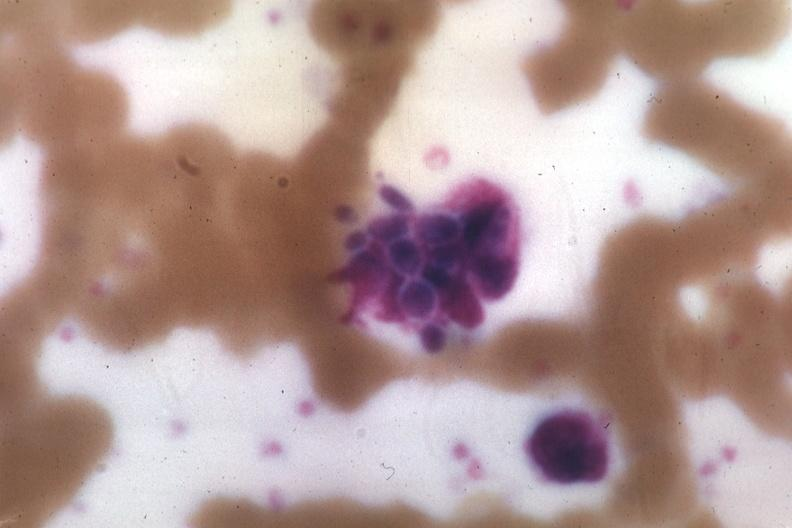what is present?
Answer the question using a single word or phrase. Candida in peripheral blood 